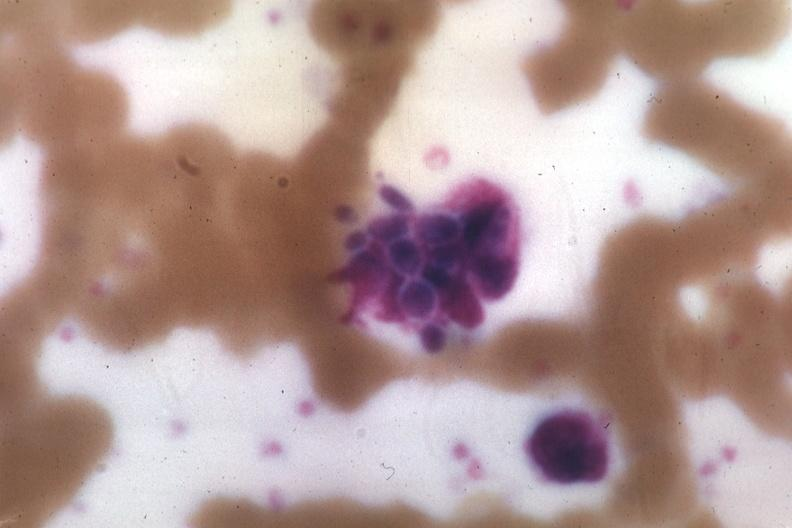what is present?
Answer the question using a single word or phrase. Candida in peripheral blood 